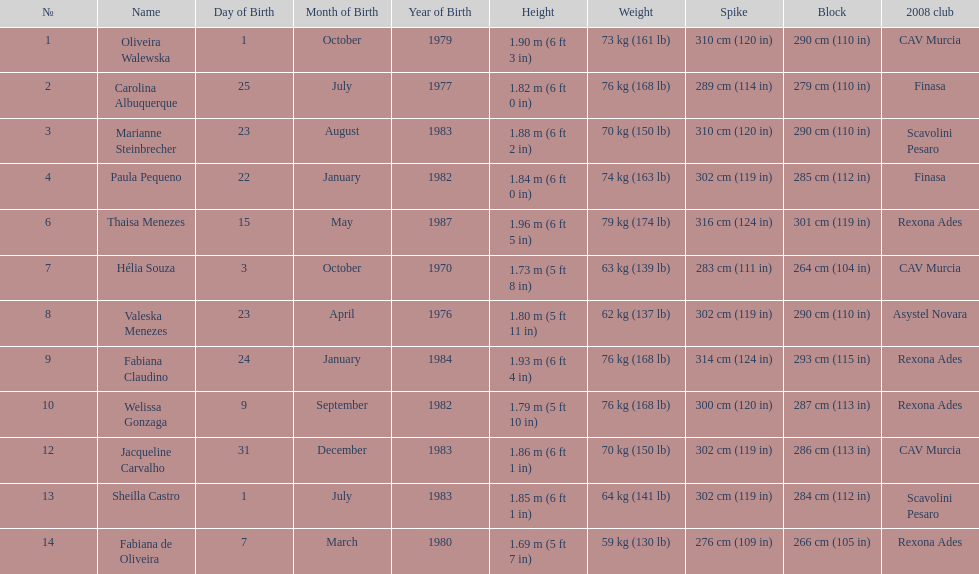Which player is the shortest at only 5 ft 7 in? Fabiana de Oliveira. 